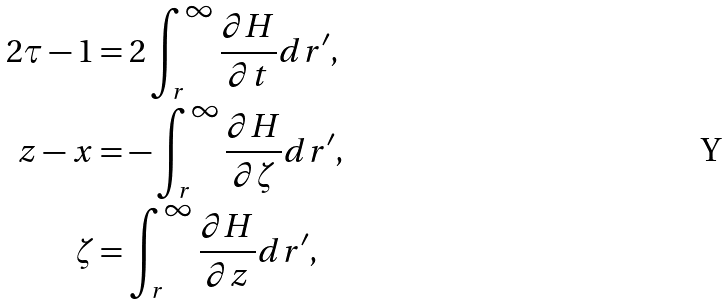Convert formula to latex. <formula><loc_0><loc_0><loc_500><loc_500>2 \tau - 1 & = 2 \int _ { r } ^ { \infty } \frac { \partial H } { \partial t } d r ^ { \prime } , \\ z - x & = - \int _ { r } ^ { \infty } \frac { \partial H } { \partial \zeta } d r ^ { \prime } , \\ \zeta & = \int _ { r } ^ { \infty } \frac { \partial H } { \partial z } d r ^ { \prime } ,</formula> 